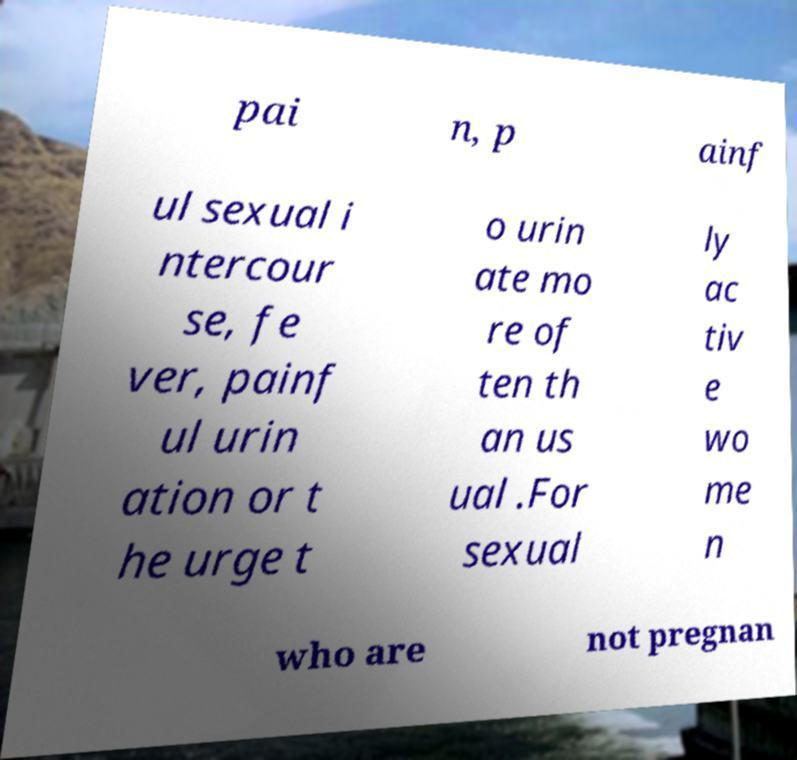Please read and relay the text visible in this image. What does it say? pai n, p ainf ul sexual i ntercour se, fe ver, painf ul urin ation or t he urge t o urin ate mo re of ten th an us ual .For sexual ly ac tiv e wo me n who are not pregnan 